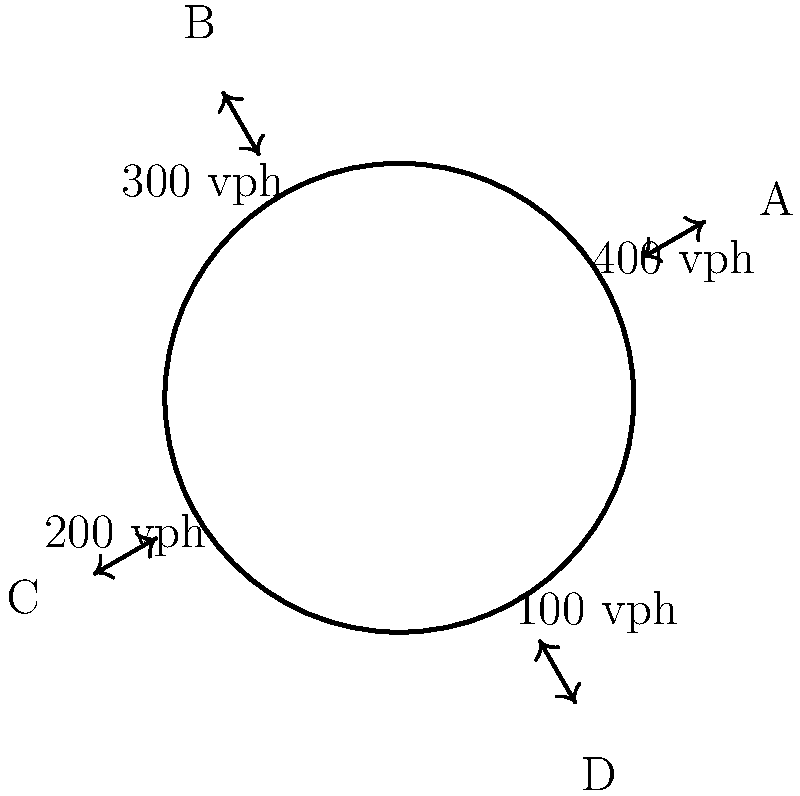As a graphic designer contributing to a Superfan blog, you're tasked with creating an infographic about traffic flow in a roundabout. The diagram shows a four-way roundabout with entry points A, B, C, and D. Given the hourly flow rates (in vehicles per hour) entering the roundabout at each point, what is the maximum flow rate within the roundabout, assuming no vehicles exit at their entry point? To find the maximum flow rate within the roundabout, we need to follow these steps:

1. Identify the flow rates entering at each point:
   A: 400 vph (vehicles per hour)
   B: 300 vph
   C: 200 vph
   D: 100 vph

2. Calculate the cumulative flow at each section of the roundabout:
   a) Between A and B: 400 vph
   b) Between B and C: 400 + 300 = 700 vph
   c) Between C and D: 400 + 300 + 200 = 900 vph
   d) Between D and A: 400 + 300 + 200 + 100 = 1000 vph

3. Identify the maximum flow rate:
   The maximum flow rate occurs between points D and A, which is 1000 vph.

4. Consider the assumption:
   We assume no vehicles exit at their entry point, which means all vehicles continue through the roundabout past their entry point.

5. Visualize the result:
   In the infographic, you would highlight the section between D and A as having the highest flow rate of 1000 vph.
Answer: 1000 vph 